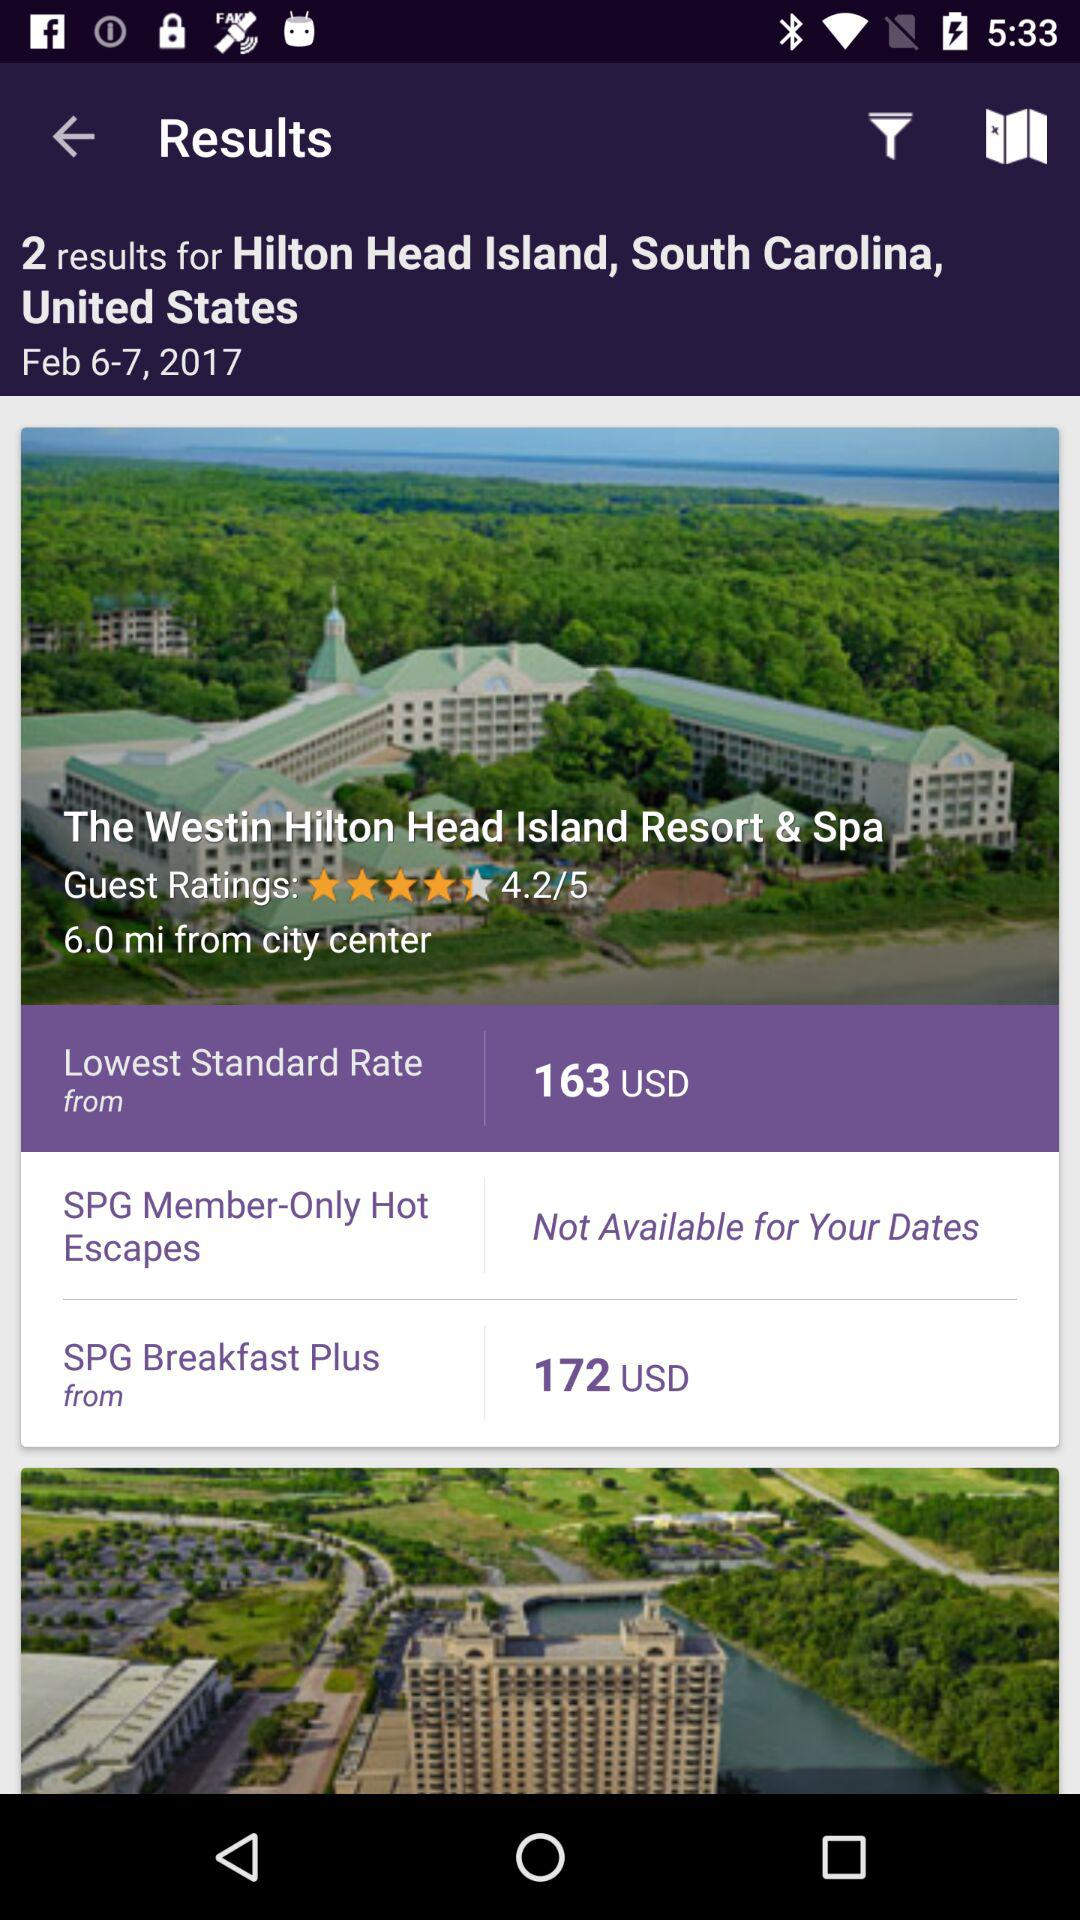How many hotels are there in the results?
Answer the question using a single word or phrase. 2 